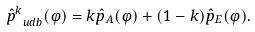Convert formula to latex. <formula><loc_0><loc_0><loc_500><loc_500>\hat { p } _ { \ u d b } ^ { k } ( \varphi ) = k \hat { p } _ { A } ( \varphi ) + ( 1 - k ) \hat { p } _ { E } ( \varphi ) .</formula> 